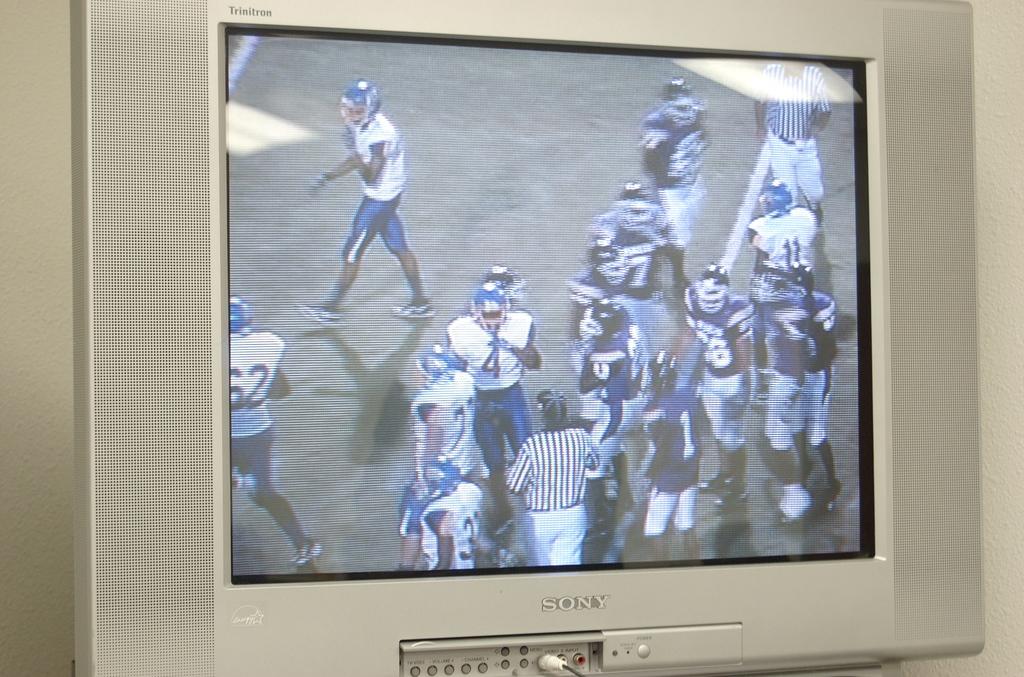What brand is the tv?
Keep it short and to the point. Sony. 